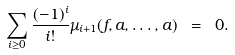Convert formula to latex. <formula><loc_0><loc_0><loc_500><loc_500>\sum _ { i \geq 0 } \frac { ( - 1 ) ^ { i } } { i ! } \mu _ { i + 1 } ( f , a , \dots , a ) \ = \ 0 .</formula> 